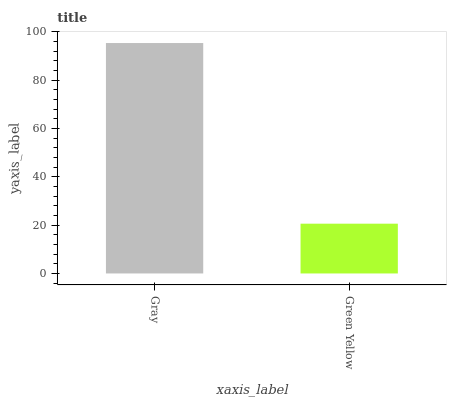Is Green Yellow the maximum?
Answer yes or no. No. Is Gray greater than Green Yellow?
Answer yes or no. Yes. Is Green Yellow less than Gray?
Answer yes or no. Yes. Is Green Yellow greater than Gray?
Answer yes or no. No. Is Gray less than Green Yellow?
Answer yes or no. No. Is Gray the high median?
Answer yes or no. Yes. Is Green Yellow the low median?
Answer yes or no. Yes. Is Green Yellow the high median?
Answer yes or no. No. Is Gray the low median?
Answer yes or no. No. 